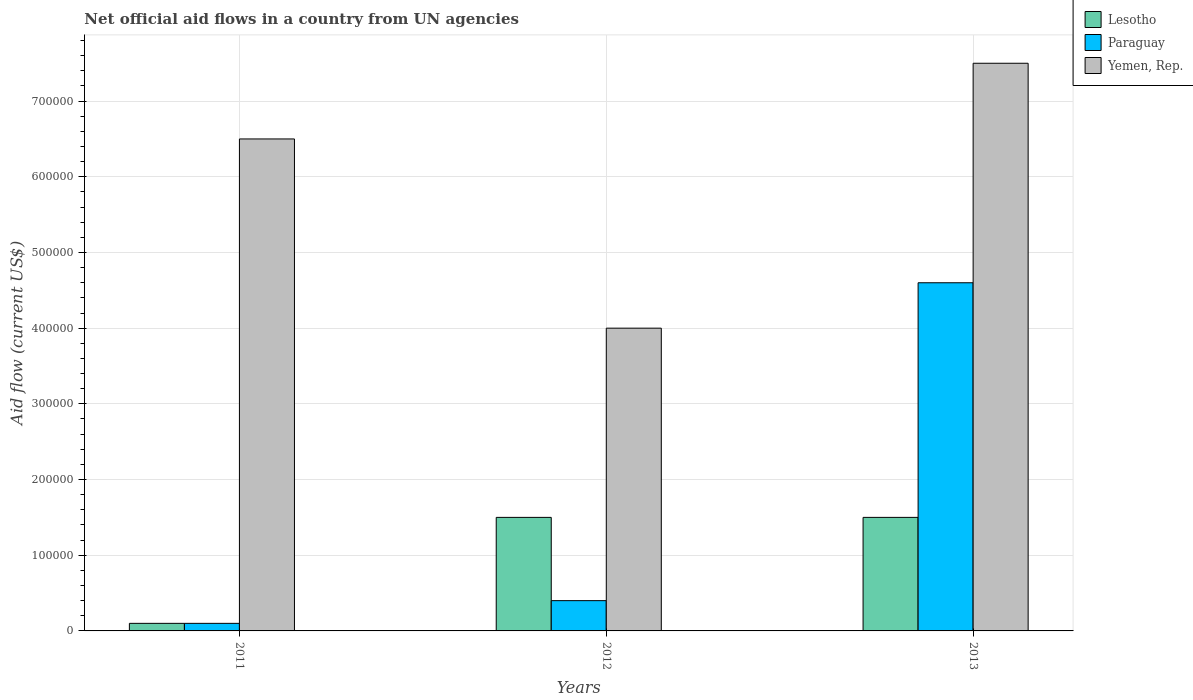How many groups of bars are there?
Ensure brevity in your answer.  3. Are the number of bars per tick equal to the number of legend labels?
Provide a succinct answer. Yes. Are the number of bars on each tick of the X-axis equal?
Your answer should be compact. Yes. How many bars are there on the 1st tick from the left?
Your answer should be very brief. 3. What is the net official aid flow in Lesotho in 2013?
Provide a succinct answer. 1.50e+05. Across all years, what is the maximum net official aid flow in Paraguay?
Your response must be concise. 4.60e+05. Across all years, what is the minimum net official aid flow in Lesotho?
Keep it short and to the point. 10000. In which year was the net official aid flow in Yemen, Rep. maximum?
Keep it short and to the point. 2013. In which year was the net official aid flow in Lesotho minimum?
Offer a terse response. 2011. What is the total net official aid flow in Paraguay in the graph?
Give a very brief answer. 5.10e+05. What is the difference between the net official aid flow in Lesotho in 2012 and that in 2013?
Your answer should be compact. 0. What is the difference between the net official aid flow in Lesotho in 2012 and the net official aid flow in Yemen, Rep. in 2013?
Keep it short and to the point. -6.00e+05. In the year 2013, what is the difference between the net official aid flow in Yemen, Rep. and net official aid flow in Lesotho?
Provide a succinct answer. 6.00e+05. What is the ratio of the net official aid flow in Paraguay in 2011 to that in 2013?
Your answer should be compact. 0.02. What is the difference between the highest and the second highest net official aid flow in Paraguay?
Your answer should be very brief. 4.20e+05. What is the difference between the highest and the lowest net official aid flow in Yemen, Rep.?
Keep it short and to the point. 3.50e+05. In how many years, is the net official aid flow in Paraguay greater than the average net official aid flow in Paraguay taken over all years?
Offer a terse response. 1. What does the 2nd bar from the left in 2013 represents?
Provide a short and direct response. Paraguay. What does the 3rd bar from the right in 2012 represents?
Give a very brief answer. Lesotho. How many bars are there?
Your answer should be compact. 9. Are all the bars in the graph horizontal?
Offer a terse response. No. Does the graph contain any zero values?
Your answer should be compact. No. Where does the legend appear in the graph?
Make the answer very short. Top right. How are the legend labels stacked?
Make the answer very short. Vertical. What is the title of the graph?
Offer a very short reply. Net official aid flows in a country from UN agencies. What is the label or title of the Y-axis?
Offer a very short reply. Aid flow (current US$). What is the Aid flow (current US$) of Yemen, Rep. in 2011?
Your response must be concise. 6.50e+05. What is the Aid flow (current US$) in Paraguay in 2012?
Your response must be concise. 4.00e+04. What is the Aid flow (current US$) of Yemen, Rep. in 2012?
Make the answer very short. 4.00e+05. What is the Aid flow (current US$) in Yemen, Rep. in 2013?
Your answer should be compact. 7.50e+05. Across all years, what is the maximum Aid flow (current US$) in Paraguay?
Your answer should be very brief. 4.60e+05. Across all years, what is the maximum Aid flow (current US$) of Yemen, Rep.?
Provide a succinct answer. 7.50e+05. Across all years, what is the minimum Aid flow (current US$) of Lesotho?
Your response must be concise. 10000. Across all years, what is the minimum Aid flow (current US$) of Yemen, Rep.?
Give a very brief answer. 4.00e+05. What is the total Aid flow (current US$) in Lesotho in the graph?
Provide a short and direct response. 3.10e+05. What is the total Aid flow (current US$) in Paraguay in the graph?
Your answer should be compact. 5.10e+05. What is the total Aid flow (current US$) in Yemen, Rep. in the graph?
Offer a very short reply. 1.80e+06. What is the difference between the Aid flow (current US$) of Lesotho in 2011 and that in 2012?
Your response must be concise. -1.40e+05. What is the difference between the Aid flow (current US$) of Yemen, Rep. in 2011 and that in 2012?
Keep it short and to the point. 2.50e+05. What is the difference between the Aid flow (current US$) of Lesotho in 2011 and that in 2013?
Your response must be concise. -1.40e+05. What is the difference between the Aid flow (current US$) in Paraguay in 2011 and that in 2013?
Offer a terse response. -4.50e+05. What is the difference between the Aid flow (current US$) of Yemen, Rep. in 2011 and that in 2013?
Provide a succinct answer. -1.00e+05. What is the difference between the Aid flow (current US$) in Lesotho in 2012 and that in 2013?
Give a very brief answer. 0. What is the difference between the Aid flow (current US$) in Paraguay in 2012 and that in 2013?
Your answer should be very brief. -4.20e+05. What is the difference between the Aid flow (current US$) of Yemen, Rep. in 2012 and that in 2013?
Make the answer very short. -3.50e+05. What is the difference between the Aid flow (current US$) of Lesotho in 2011 and the Aid flow (current US$) of Paraguay in 2012?
Your response must be concise. -3.00e+04. What is the difference between the Aid flow (current US$) of Lesotho in 2011 and the Aid flow (current US$) of Yemen, Rep. in 2012?
Your answer should be very brief. -3.90e+05. What is the difference between the Aid flow (current US$) of Paraguay in 2011 and the Aid flow (current US$) of Yemen, Rep. in 2012?
Provide a succinct answer. -3.90e+05. What is the difference between the Aid flow (current US$) in Lesotho in 2011 and the Aid flow (current US$) in Paraguay in 2013?
Ensure brevity in your answer.  -4.50e+05. What is the difference between the Aid flow (current US$) of Lesotho in 2011 and the Aid flow (current US$) of Yemen, Rep. in 2013?
Provide a succinct answer. -7.40e+05. What is the difference between the Aid flow (current US$) in Paraguay in 2011 and the Aid flow (current US$) in Yemen, Rep. in 2013?
Ensure brevity in your answer.  -7.40e+05. What is the difference between the Aid flow (current US$) of Lesotho in 2012 and the Aid flow (current US$) of Paraguay in 2013?
Provide a short and direct response. -3.10e+05. What is the difference between the Aid flow (current US$) in Lesotho in 2012 and the Aid flow (current US$) in Yemen, Rep. in 2013?
Provide a short and direct response. -6.00e+05. What is the difference between the Aid flow (current US$) in Paraguay in 2012 and the Aid flow (current US$) in Yemen, Rep. in 2013?
Offer a terse response. -7.10e+05. What is the average Aid flow (current US$) in Lesotho per year?
Provide a short and direct response. 1.03e+05. What is the average Aid flow (current US$) in Paraguay per year?
Your response must be concise. 1.70e+05. What is the average Aid flow (current US$) of Yemen, Rep. per year?
Ensure brevity in your answer.  6.00e+05. In the year 2011, what is the difference between the Aid flow (current US$) in Lesotho and Aid flow (current US$) in Yemen, Rep.?
Your response must be concise. -6.40e+05. In the year 2011, what is the difference between the Aid flow (current US$) in Paraguay and Aid flow (current US$) in Yemen, Rep.?
Offer a very short reply. -6.40e+05. In the year 2012, what is the difference between the Aid flow (current US$) in Lesotho and Aid flow (current US$) in Paraguay?
Offer a very short reply. 1.10e+05. In the year 2012, what is the difference between the Aid flow (current US$) of Lesotho and Aid flow (current US$) of Yemen, Rep.?
Give a very brief answer. -2.50e+05. In the year 2012, what is the difference between the Aid flow (current US$) of Paraguay and Aid flow (current US$) of Yemen, Rep.?
Your answer should be compact. -3.60e+05. In the year 2013, what is the difference between the Aid flow (current US$) in Lesotho and Aid flow (current US$) in Paraguay?
Your answer should be very brief. -3.10e+05. In the year 2013, what is the difference between the Aid flow (current US$) in Lesotho and Aid flow (current US$) in Yemen, Rep.?
Your answer should be compact. -6.00e+05. In the year 2013, what is the difference between the Aid flow (current US$) of Paraguay and Aid flow (current US$) of Yemen, Rep.?
Offer a terse response. -2.90e+05. What is the ratio of the Aid flow (current US$) of Lesotho in 2011 to that in 2012?
Ensure brevity in your answer.  0.07. What is the ratio of the Aid flow (current US$) in Yemen, Rep. in 2011 to that in 2012?
Keep it short and to the point. 1.62. What is the ratio of the Aid flow (current US$) of Lesotho in 2011 to that in 2013?
Your answer should be very brief. 0.07. What is the ratio of the Aid flow (current US$) in Paraguay in 2011 to that in 2013?
Your answer should be very brief. 0.02. What is the ratio of the Aid flow (current US$) in Yemen, Rep. in 2011 to that in 2013?
Give a very brief answer. 0.87. What is the ratio of the Aid flow (current US$) in Lesotho in 2012 to that in 2013?
Keep it short and to the point. 1. What is the ratio of the Aid flow (current US$) in Paraguay in 2012 to that in 2013?
Make the answer very short. 0.09. What is the ratio of the Aid flow (current US$) in Yemen, Rep. in 2012 to that in 2013?
Keep it short and to the point. 0.53. What is the difference between the highest and the second highest Aid flow (current US$) in Paraguay?
Your answer should be compact. 4.20e+05. 